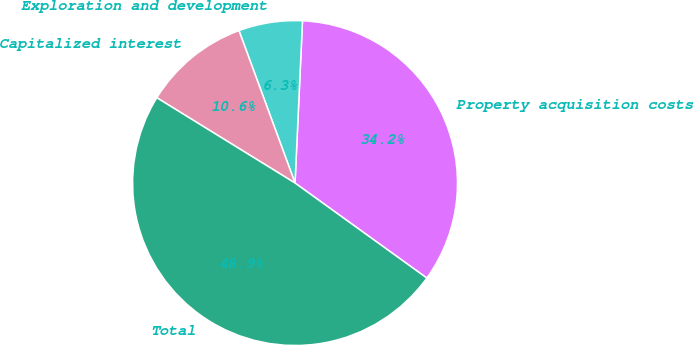Convert chart. <chart><loc_0><loc_0><loc_500><loc_500><pie_chart><fcel>Property acquisition costs<fcel>Exploration and development<fcel>Capitalized interest<fcel>Total<nl><fcel>34.21%<fcel>6.34%<fcel>10.59%<fcel>48.86%<nl></chart> 